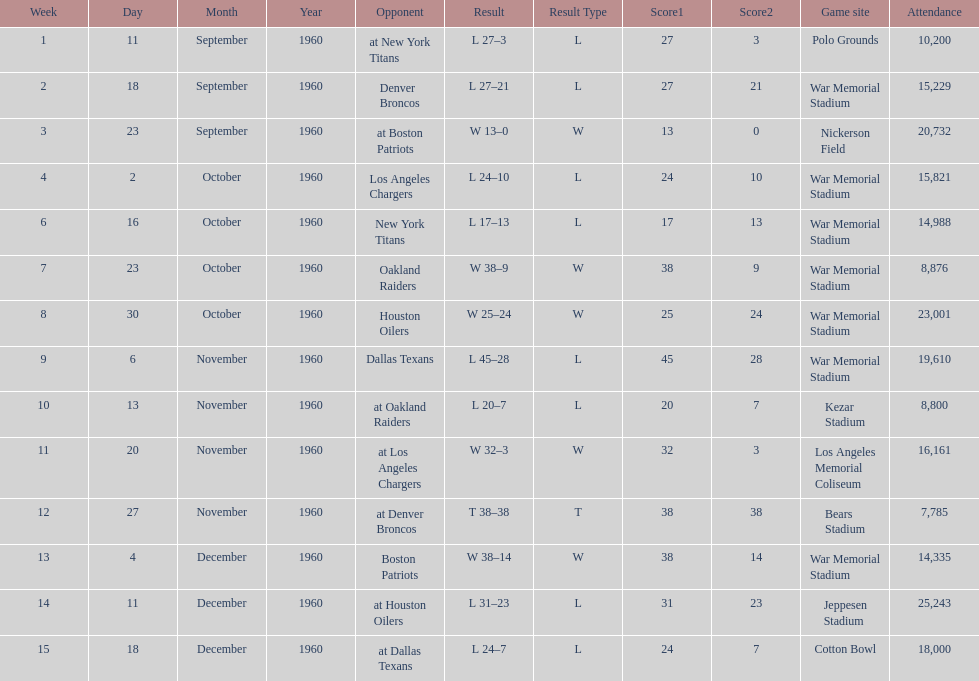Who did the bills play after the oakland raiders? Houston Oilers. 